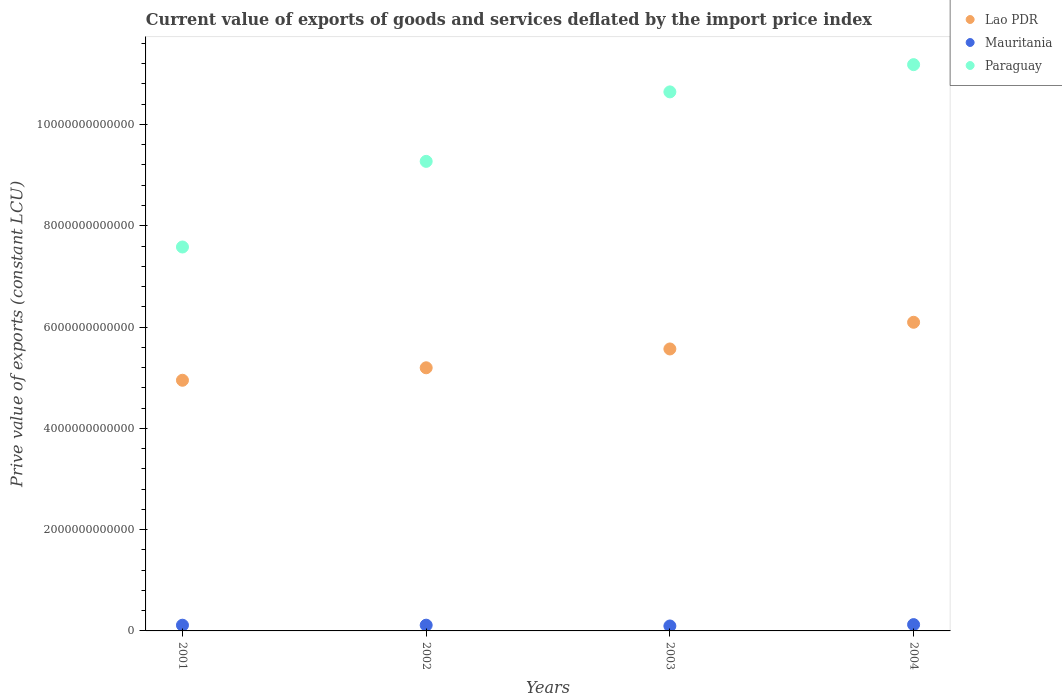How many different coloured dotlines are there?
Your answer should be very brief. 3. Is the number of dotlines equal to the number of legend labels?
Your answer should be very brief. Yes. What is the prive value of exports in Lao PDR in 2003?
Provide a succinct answer. 5.57e+12. Across all years, what is the maximum prive value of exports in Paraguay?
Provide a succinct answer. 1.12e+13. Across all years, what is the minimum prive value of exports in Lao PDR?
Your answer should be compact. 4.95e+12. In which year was the prive value of exports in Paraguay minimum?
Keep it short and to the point. 2001. What is the total prive value of exports in Mauritania in the graph?
Make the answer very short. 4.49e+11. What is the difference between the prive value of exports in Paraguay in 2001 and that in 2002?
Offer a very short reply. -1.69e+12. What is the difference between the prive value of exports in Paraguay in 2003 and the prive value of exports in Mauritania in 2001?
Your answer should be very brief. 1.05e+13. What is the average prive value of exports in Lao PDR per year?
Make the answer very short. 5.45e+12. In the year 2001, what is the difference between the prive value of exports in Paraguay and prive value of exports in Lao PDR?
Provide a short and direct response. 2.63e+12. What is the ratio of the prive value of exports in Mauritania in 2002 to that in 2003?
Provide a short and direct response. 1.16. Is the prive value of exports in Lao PDR in 2002 less than that in 2004?
Provide a short and direct response. Yes. Is the difference between the prive value of exports in Paraguay in 2001 and 2002 greater than the difference between the prive value of exports in Lao PDR in 2001 and 2002?
Make the answer very short. No. What is the difference between the highest and the second highest prive value of exports in Paraguay?
Provide a succinct answer. 5.38e+11. What is the difference between the highest and the lowest prive value of exports in Lao PDR?
Your answer should be very brief. 1.14e+12. How many dotlines are there?
Keep it short and to the point. 3. How many years are there in the graph?
Give a very brief answer. 4. What is the difference between two consecutive major ticks on the Y-axis?
Give a very brief answer. 2.00e+12. Does the graph contain any zero values?
Provide a short and direct response. No. Where does the legend appear in the graph?
Keep it short and to the point. Top right. How are the legend labels stacked?
Offer a very short reply. Vertical. What is the title of the graph?
Provide a short and direct response. Current value of exports of goods and services deflated by the import price index. What is the label or title of the X-axis?
Provide a succinct answer. Years. What is the label or title of the Y-axis?
Make the answer very short. Prive value of exports (constant LCU). What is the Prive value of exports (constant LCU) of Lao PDR in 2001?
Keep it short and to the point. 4.95e+12. What is the Prive value of exports (constant LCU) of Mauritania in 2001?
Your answer should be compact. 1.13e+11. What is the Prive value of exports (constant LCU) in Paraguay in 2001?
Provide a succinct answer. 7.58e+12. What is the Prive value of exports (constant LCU) of Lao PDR in 2002?
Provide a short and direct response. 5.20e+12. What is the Prive value of exports (constant LCU) of Mauritania in 2002?
Offer a very short reply. 1.14e+11. What is the Prive value of exports (constant LCU) of Paraguay in 2002?
Ensure brevity in your answer.  9.27e+12. What is the Prive value of exports (constant LCU) of Lao PDR in 2003?
Your answer should be very brief. 5.57e+12. What is the Prive value of exports (constant LCU) in Mauritania in 2003?
Keep it short and to the point. 9.78e+1. What is the Prive value of exports (constant LCU) in Paraguay in 2003?
Offer a very short reply. 1.06e+13. What is the Prive value of exports (constant LCU) in Lao PDR in 2004?
Your response must be concise. 6.09e+12. What is the Prive value of exports (constant LCU) in Mauritania in 2004?
Keep it short and to the point. 1.25e+11. What is the Prive value of exports (constant LCU) of Paraguay in 2004?
Your response must be concise. 1.12e+13. Across all years, what is the maximum Prive value of exports (constant LCU) of Lao PDR?
Offer a very short reply. 6.09e+12. Across all years, what is the maximum Prive value of exports (constant LCU) in Mauritania?
Provide a short and direct response. 1.25e+11. Across all years, what is the maximum Prive value of exports (constant LCU) in Paraguay?
Offer a very short reply. 1.12e+13. Across all years, what is the minimum Prive value of exports (constant LCU) in Lao PDR?
Offer a very short reply. 4.95e+12. Across all years, what is the minimum Prive value of exports (constant LCU) of Mauritania?
Offer a terse response. 9.78e+1. Across all years, what is the minimum Prive value of exports (constant LCU) of Paraguay?
Provide a short and direct response. 7.58e+12. What is the total Prive value of exports (constant LCU) of Lao PDR in the graph?
Offer a very short reply. 2.18e+13. What is the total Prive value of exports (constant LCU) of Mauritania in the graph?
Keep it short and to the point. 4.49e+11. What is the total Prive value of exports (constant LCU) of Paraguay in the graph?
Provide a succinct answer. 3.87e+13. What is the difference between the Prive value of exports (constant LCU) in Lao PDR in 2001 and that in 2002?
Provide a short and direct response. -2.46e+11. What is the difference between the Prive value of exports (constant LCU) in Mauritania in 2001 and that in 2002?
Your response must be concise. -6.69e+08. What is the difference between the Prive value of exports (constant LCU) in Paraguay in 2001 and that in 2002?
Your answer should be very brief. -1.69e+12. What is the difference between the Prive value of exports (constant LCU) of Lao PDR in 2001 and that in 2003?
Provide a succinct answer. -6.18e+11. What is the difference between the Prive value of exports (constant LCU) of Mauritania in 2001 and that in 2003?
Provide a short and direct response. 1.51e+1. What is the difference between the Prive value of exports (constant LCU) in Paraguay in 2001 and that in 2003?
Your answer should be compact. -3.06e+12. What is the difference between the Prive value of exports (constant LCU) in Lao PDR in 2001 and that in 2004?
Give a very brief answer. -1.14e+12. What is the difference between the Prive value of exports (constant LCU) in Mauritania in 2001 and that in 2004?
Give a very brief answer. -1.18e+1. What is the difference between the Prive value of exports (constant LCU) of Paraguay in 2001 and that in 2004?
Offer a very short reply. -3.60e+12. What is the difference between the Prive value of exports (constant LCU) of Lao PDR in 2002 and that in 2003?
Ensure brevity in your answer.  -3.72e+11. What is the difference between the Prive value of exports (constant LCU) of Mauritania in 2002 and that in 2003?
Your answer should be compact. 1.57e+1. What is the difference between the Prive value of exports (constant LCU) in Paraguay in 2002 and that in 2003?
Offer a very short reply. -1.37e+12. What is the difference between the Prive value of exports (constant LCU) in Lao PDR in 2002 and that in 2004?
Your answer should be very brief. -8.99e+11. What is the difference between the Prive value of exports (constant LCU) in Mauritania in 2002 and that in 2004?
Keep it short and to the point. -1.11e+1. What is the difference between the Prive value of exports (constant LCU) in Paraguay in 2002 and that in 2004?
Ensure brevity in your answer.  -1.91e+12. What is the difference between the Prive value of exports (constant LCU) in Lao PDR in 2003 and that in 2004?
Ensure brevity in your answer.  -5.27e+11. What is the difference between the Prive value of exports (constant LCU) in Mauritania in 2003 and that in 2004?
Ensure brevity in your answer.  -2.69e+1. What is the difference between the Prive value of exports (constant LCU) of Paraguay in 2003 and that in 2004?
Keep it short and to the point. -5.38e+11. What is the difference between the Prive value of exports (constant LCU) in Lao PDR in 2001 and the Prive value of exports (constant LCU) in Mauritania in 2002?
Your response must be concise. 4.84e+12. What is the difference between the Prive value of exports (constant LCU) in Lao PDR in 2001 and the Prive value of exports (constant LCU) in Paraguay in 2002?
Your answer should be compact. -4.32e+12. What is the difference between the Prive value of exports (constant LCU) of Mauritania in 2001 and the Prive value of exports (constant LCU) of Paraguay in 2002?
Make the answer very short. -9.16e+12. What is the difference between the Prive value of exports (constant LCU) in Lao PDR in 2001 and the Prive value of exports (constant LCU) in Mauritania in 2003?
Give a very brief answer. 4.85e+12. What is the difference between the Prive value of exports (constant LCU) of Lao PDR in 2001 and the Prive value of exports (constant LCU) of Paraguay in 2003?
Offer a terse response. -5.69e+12. What is the difference between the Prive value of exports (constant LCU) of Mauritania in 2001 and the Prive value of exports (constant LCU) of Paraguay in 2003?
Provide a succinct answer. -1.05e+13. What is the difference between the Prive value of exports (constant LCU) of Lao PDR in 2001 and the Prive value of exports (constant LCU) of Mauritania in 2004?
Offer a very short reply. 4.82e+12. What is the difference between the Prive value of exports (constant LCU) in Lao PDR in 2001 and the Prive value of exports (constant LCU) in Paraguay in 2004?
Offer a terse response. -6.23e+12. What is the difference between the Prive value of exports (constant LCU) in Mauritania in 2001 and the Prive value of exports (constant LCU) in Paraguay in 2004?
Your response must be concise. -1.11e+13. What is the difference between the Prive value of exports (constant LCU) of Lao PDR in 2002 and the Prive value of exports (constant LCU) of Mauritania in 2003?
Keep it short and to the point. 5.10e+12. What is the difference between the Prive value of exports (constant LCU) of Lao PDR in 2002 and the Prive value of exports (constant LCU) of Paraguay in 2003?
Give a very brief answer. -5.45e+12. What is the difference between the Prive value of exports (constant LCU) in Mauritania in 2002 and the Prive value of exports (constant LCU) in Paraguay in 2003?
Your answer should be compact. -1.05e+13. What is the difference between the Prive value of exports (constant LCU) of Lao PDR in 2002 and the Prive value of exports (constant LCU) of Mauritania in 2004?
Give a very brief answer. 5.07e+12. What is the difference between the Prive value of exports (constant LCU) of Lao PDR in 2002 and the Prive value of exports (constant LCU) of Paraguay in 2004?
Your response must be concise. -5.99e+12. What is the difference between the Prive value of exports (constant LCU) in Mauritania in 2002 and the Prive value of exports (constant LCU) in Paraguay in 2004?
Offer a very short reply. -1.11e+13. What is the difference between the Prive value of exports (constant LCU) in Lao PDR in 2003 and the Prive value of exports (constant LCU) in Mauritania in 2004?
Give a very brief answer. 5.44e+12. What is the difference between the Prive value of exports (constant LCU) in Lao PDR in 2003 and the Prive value of exports (constant LCU) in Paraguay in 2004?
Offer a terse response. -5.61e+12. What is the difference between the Prive value of exports (constant LCU) of Mauritania in 2003 and the Prive value of exports (constant LCU) of Paraguay in 2004?
Make the answer very short. -1.11e+13. What is the average Prive value of exports (constant LCU) of Lao PDR per year?
Keep it short and to the point. 5.45e+12. What is the average Prive value of exports (constant LCU) in Mauritania per year?
Offer a very short reply. 1.12e+11. What is the average Prive value of exports (constant LCU) of Paraguay per year?
Ensure brevity in your answer.  9.67e+12. In the year 2001, what is the difference between the Prive value of exports (constant LCU) in Lao PDR and Prive value of exports (constant LCU) in Mauritania?
Offer a terse response. 4.84e+12. In the year 2001, what is the difference between the Prive value of exports (constant LCU) in Lao PDR and Prive value of exports (constant LCU) in Paraguay?
Your answer should be compact. -2.63e+12. In the year 2001, what is the difference between the Prive value of exports (constant LCU) in Mauritania and Prive value of exports (constant LCU) in Paraguay?
Your answer should be compact. -7.47e+12. In the year 2002, what is the difference between the Prive value of exports (constant LCU) in Lao PDR and Prive value of exports (constant LCU) in Mauritania?
Make the answer very short. 5.08e+12. In the year 2002, what is the difference between the Prive value of exports (constant LCU) of Lao PDR and Prive value of exports (constant LCU) of Paraguay?
Make the answer very short. -4.08e+12. In the year 2002, what is the difference between the Prive value of exports (constant LCU) of Mauritania and Prive value of exports (constant LCU) of Paraguay?
Your answer should be compact. -9.16e+12. In the year 2003, what is the difference between the Prive value of exports (constant LCU) in Lao PDR and Prive value of exports (constant LCU) in Mauritania?
Your answer should be very brief. 5.47e+12. In the year 2003, what is the difference between the Prive value of exports (constant LCU) in Lao PDR and Prive value of exports (constant LCU) in Paraguay?
Keep it short and to the point. -5.08e+12. In the year 2003, what is the difference between the Prive value of exports (constant LCU) in Mauritania and Prive value of exports (constant LCU) in Paraguay?
Offer a terse response. -1.05e+13. In the year 2004, what is the difference between the Prive value of exports (constant LCU) in Lao PDR and Prive value of exports (constant LCU) in Mauritania?
Ensure brevity in your answer.  5.97e+12. In the year 2004, what is the difference between the Prive value of exports (constant LCU) of Lao PDR and Prive value of exports (constant LCU) of Paraguay?
Your response must be concise. -5.09e+12. In the year 2004, what is the difference between the Prive value of exports (constant LCU) of Mauritania and Prive value of exports (constant LCU) of Paraguay?
Make the answer very short. -1.11e+13. What is the ratio of the Prive value of exports (constant LCU) of Lao PDR in 2001 to that in 2002?
Make the answer very short. 0.95. What is the ratio of the Prive value of exports (constant LCU) in Paraguay in 2001 to that in 2002?
Give a very brief answer. 0.82. What is the ratio of the Prive value of exports (constant LCU) in Lao PDR in 2001 to that in 2003?
Ensure brevity in your answer.  0.89. What is the ratio of the Prive value of exports (constant LCU) of Mauritania in 2001 to that in 2003?
Provide a short and direct response. 1.15. What is the ratio of the Prive value of exports (constant LCU) in Paraguay in 2001 to that in 2003?
Your response must be concise. 0.71. What is the ratio of the Prive value of exports (constant LCU) of Lao PDR in 2001 to that in 2004?
Keep it short and to the point. 0.81. What is the ratio of the Prive value of exports (constant LCU) of Mauritania in 2001 to that in 2004?
Ensure brevity in your answer.  0.91. What is the ratio of the Prive value of exports (constant LCU) in Paraguay in 2001 to that in 2004?
Make the answer very short. 0.68. What is the ratio of the Prive value of exports (constant LCU) in Lao PDR in 2002 to that in 2003?
Make the answer very short. 0.93. What is the ratio of the Prive value of exports (constant LCU) of Mauritania in 2002 to that in 2003?
Make the answer very short. 1.16. What is the ratio of the Prive value of exports (constant LCU) in Paraguay in 2002 to that in 2003?
Keep it short and to the point. 0.87. What is the ratio of the Prive value of exports (constant LCU) of Lao PDR in 2002 to that in 2004?
Your answer should be very brief. 0.85. What is the ratio of the Prive value of exports (constant LCU) of Mauritania in 2002 to that in 2004?
Make the answer very short. 0.91. What is the ratio of the Prive value of exports (constant LCU) of Paraguay in 2002 to that in 2004?
Offer a terse response. 0.83. What is the ratio of the Prive value of exports (constant LCU) in Lao PDR in 2003 to that in 2004?
Provide a short and direct response. 0.91. What is the ratio of the Prive value of exports (constant LCU) of Mauritania in 2003 to that in 2004?
Give a very brief answer. 0.78. What is the ratio of the Prive value of exports (constant LCU) of Paraguay in 2003 to that in 2004?
Make the answer very short. 0.95. What is the difference between the highest and the second highest Prive value of exports (constant LCU) in Lao PDR?
Offer a very short reply. 5.27e+11. What is the difference between the highest and the second highest Prive value of exports (constant LCU) of Mauritania?
Keep it short and to the point. 1.11e+1. What is the difference between the highest and the second highest Prive value of exports (constant LCU) of Paraguay?
Ensure brevity in your answer.  5.38e+11. What is the difference between the highest and the lowest Prive value of exports (constant LCU) in Lao PDR?
Offer a very short reply. 1.14e+12. What is the difference between the highest and the lowest Prive value of exports (constant LCU) of Mauritania?
Ensure brevity in your answer.  2.69e+1. What is the difference between the highest and the lowest Prive value of exports (constant LCU) of Paraguay?
Ensure brevity in your answer.  3.60e+12. 